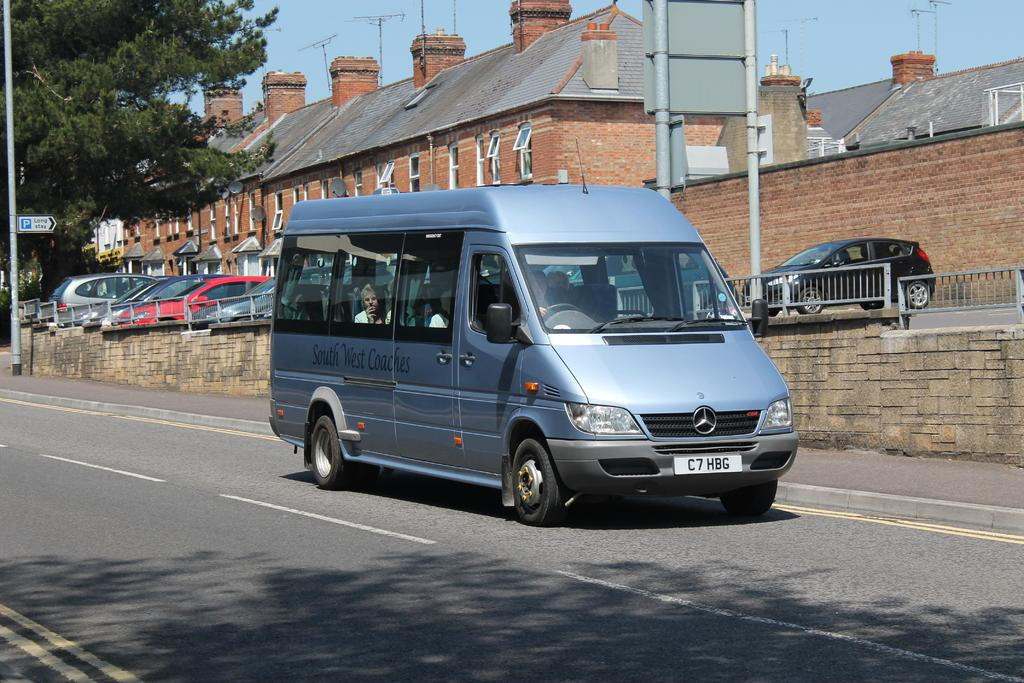<image>
Describe the image concisely. A Mercedes van with a tag on it that reads C7HBG. 